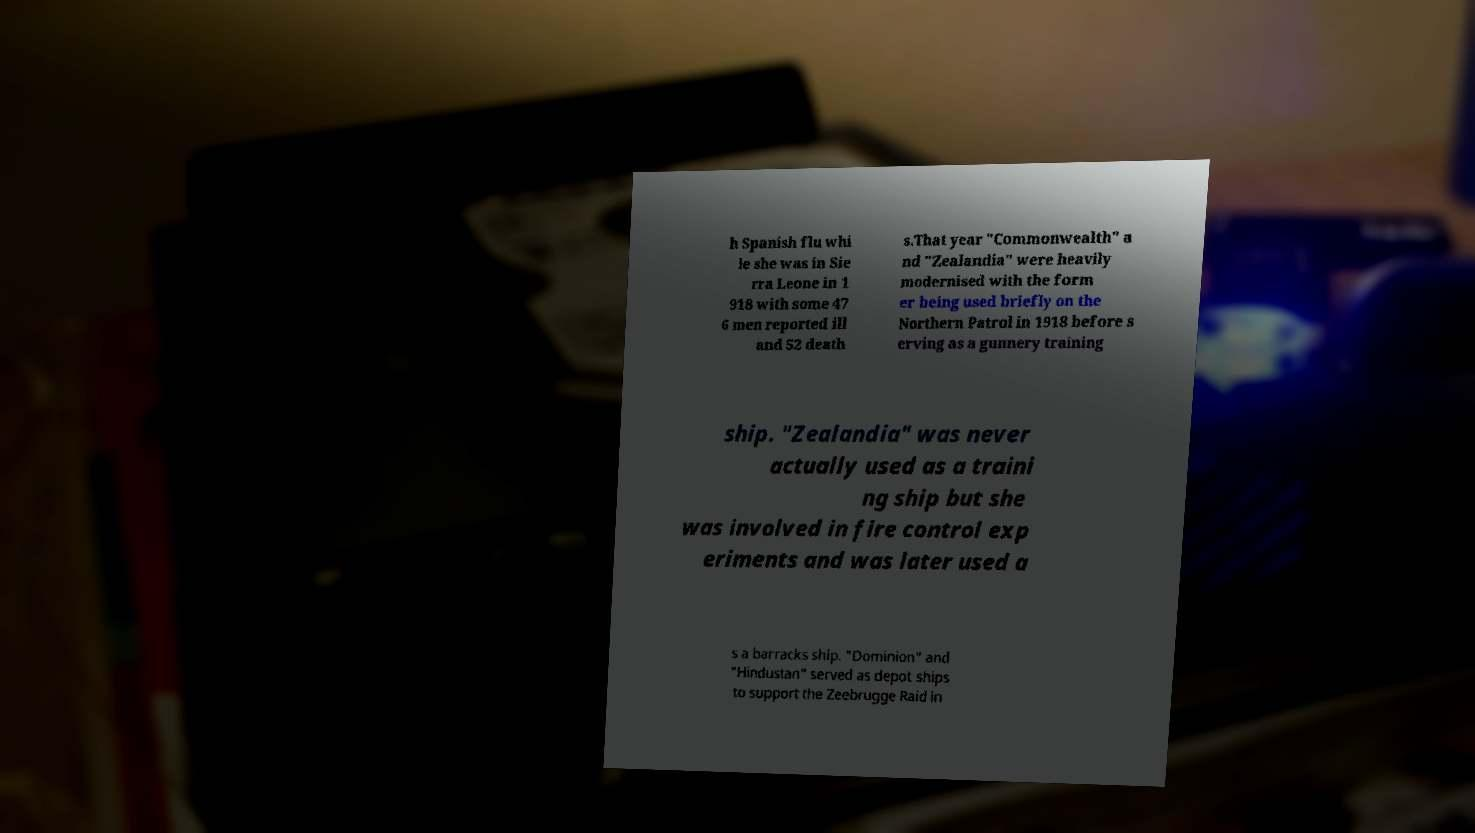What messages or text are displayed in this image? I need them in a readable, typed format. h Spanish flu whi le she was in Sie rra Leone in 1 918 with some 47 6 men reported ill and 52 death s.That year "Commonwealth" a nd "Zealandia" were heavily modernised with the form er being used briefly on the Northern Patrol in 1918 before s erving as a gunnery training ship. "Zealandia" was never actually used as a traini ng ship but she was involved in fire control exp eriments and was later used a s a barracks ship. "Dominion" and "Hindustan" served as depot ships to support the Zeebrugge Raid in 